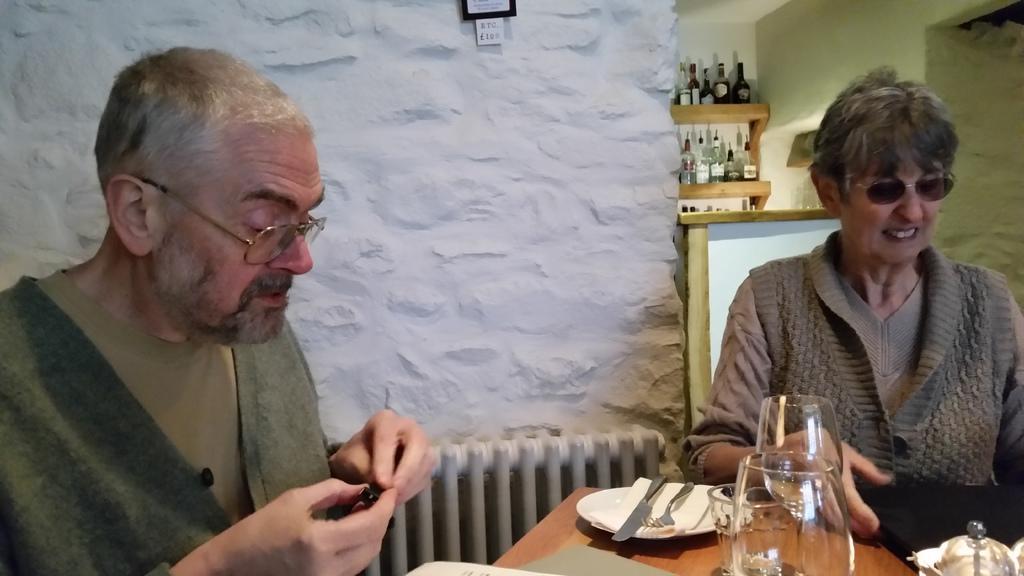Describe this image in one or two sentences. In the image we can see there are people sitting on the chair and there are wine glasses, plate, knife and fork kept on the table. Behind there is a wall and there are wine bottles kept in the racks. 